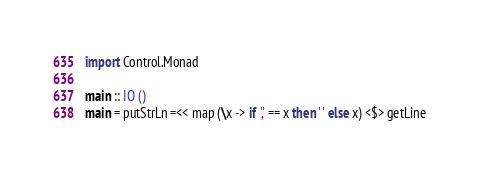Convert code to text. <code><loc_0><loc_0><loc_500><loc_500><_Haskell_>import Control.Monad

main :: IO ()
main = putStrLn =<< map (\x -> if ',' == x then ' ' else x) <$> getLine</code> 